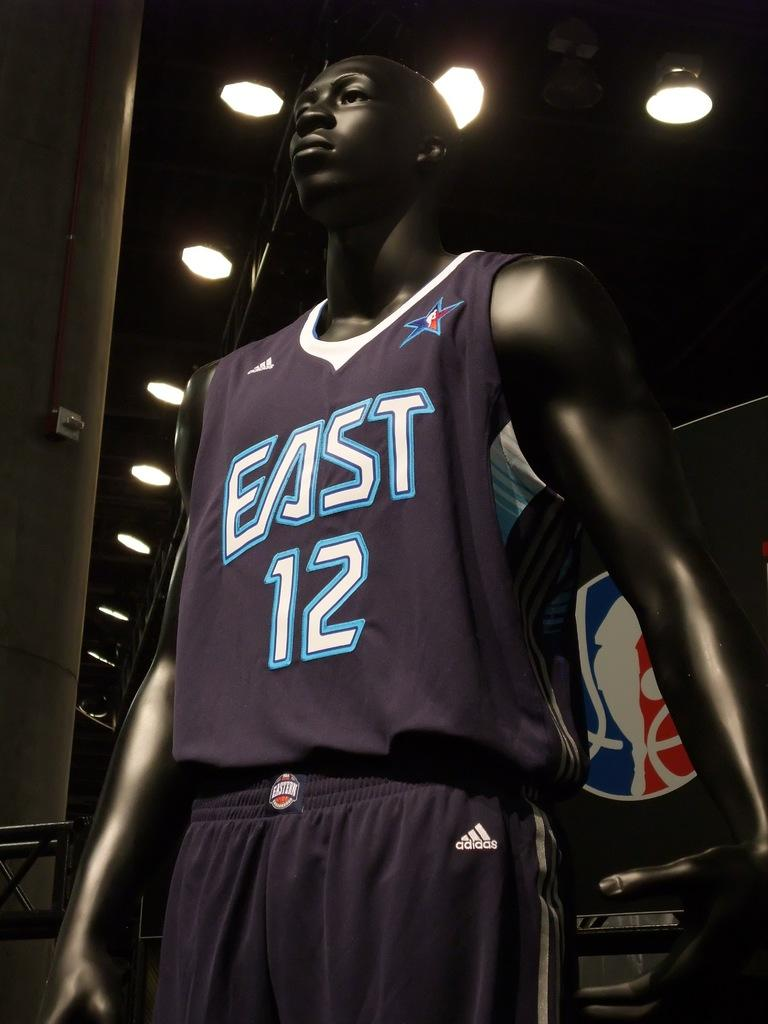<image>
Create a compact narrative representing the image presented. A jersey has the number 12 on the front. 